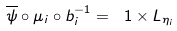Convert formula to latex. <formula><loc_0><loc_0><loc_500><loc_500>\overline { \psi } \circ \mu _ { i } \circ b _ { i } ^ { - 1 } = \ 1 \times L _ { \eta _ { i } }</formula> 